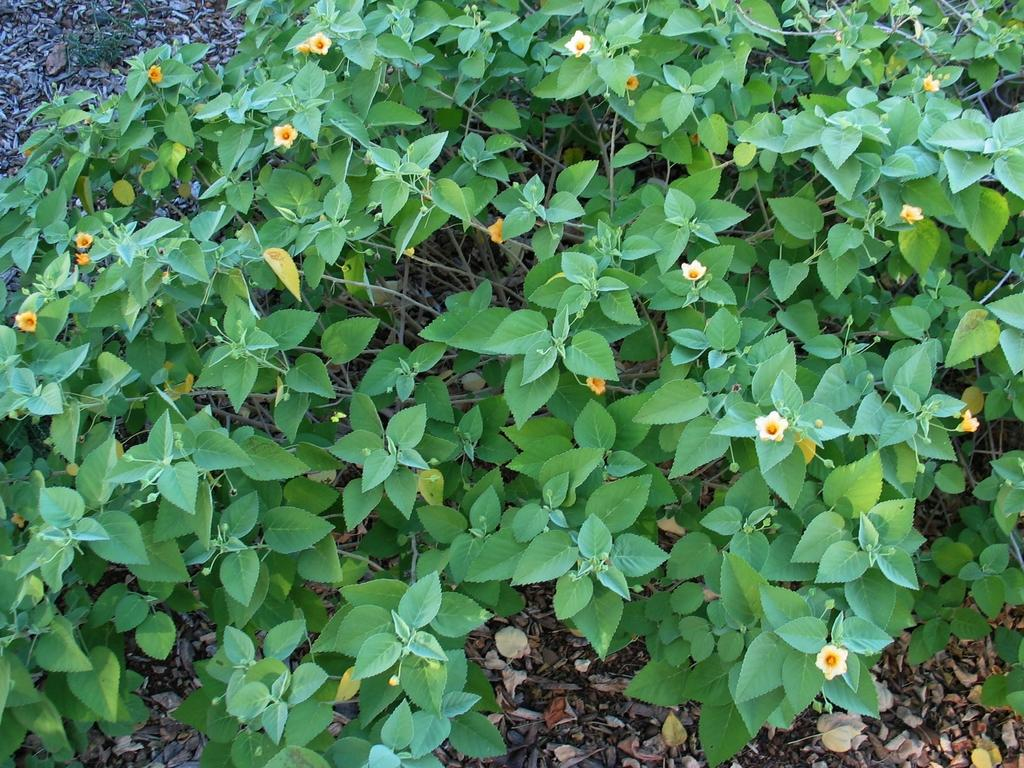What is the main subject of the image? The main subject of the image is a group of plants. What specific feature can be observed on the plants? The plants have flowers. How many feet are visible in the image? There are no feet visible in the image, as it features a group of plants with flowers. What type of apparatus is being used by the clam in the image? There is no clam present in the image, so it is not possible to determine what, if any, apparatus might be used by a clam. 